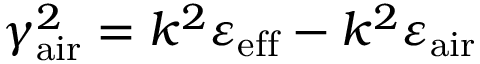<formula> <loc_0><loc_0><loc_500><loc_500>\gamma _ { a i r } ^ { 2 } = k ^ { 2 } \varepsilon _ { e f f } - k ^ { 2 } \varepsilon _ { a i r }</formula> 